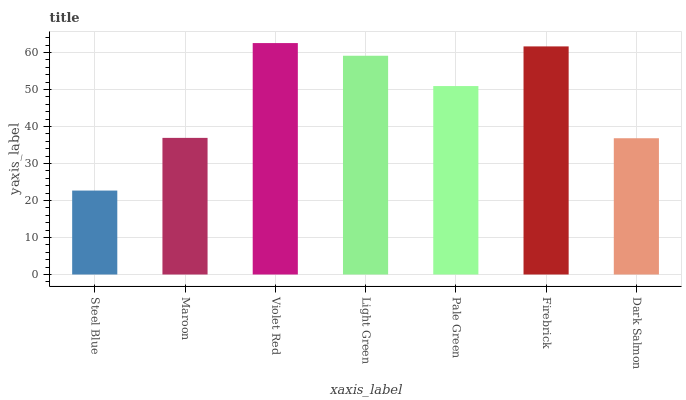Is Steel Blue the minimum?
Answer yes or no. Yes. Is Violet Red the maximum?
Answer yes or no. Yes. Is Maroon the minimum?
Answer yes or no. No. Is Maroon the maximum?
Answer yes or no. No. Is Maroon greater than Steel Blue?
Answer yes or no. Yes. Is Steel Blue less than Maroon?
Answer yes or no. Yes. Is Steel Blue greater than Maroon?
Answer yes or no. No. Is Maroon less than Steel Blue?
Answer yes or no. No. Is Pale Green the high median?
Answer yes or no. Yes. Is Pale Green the low median?
Answer yes or no. Yes. Is Steel Blue the high median?
Answer yes or no. No. Is Steel Blue the low median?
Answer yes or no. No. 